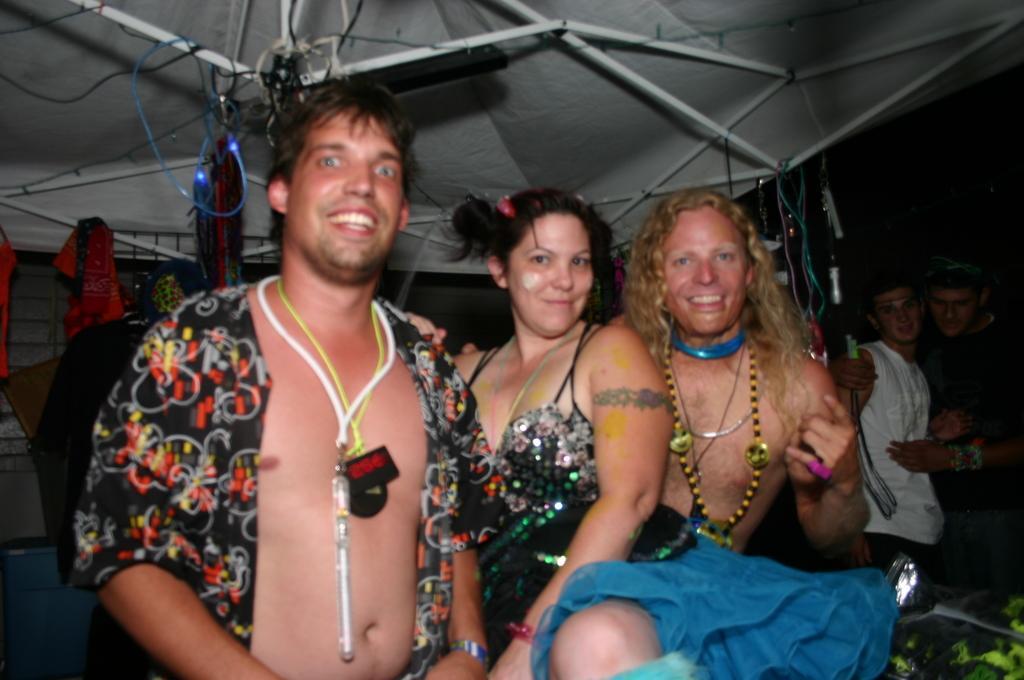Could you give a brief overview of what you see in this image? In this picture we can see few people and they are smiling and in the background we can see a tent and few objects. 